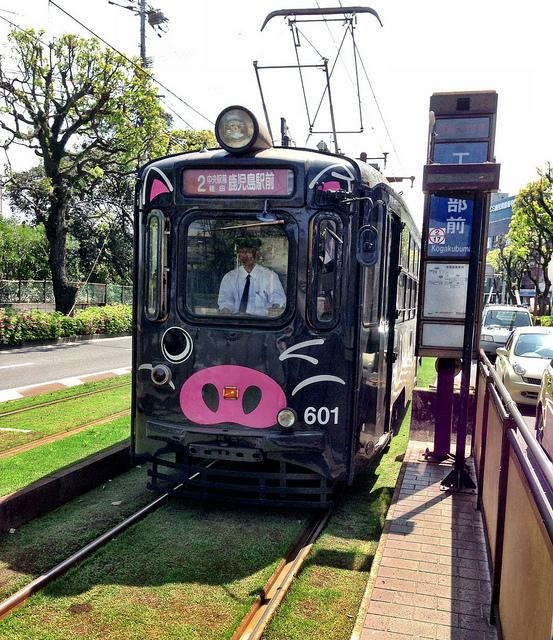How is the trolley powered?

Choices:
A) solar
B) gas
C) nuclear
D) electricity electricity 